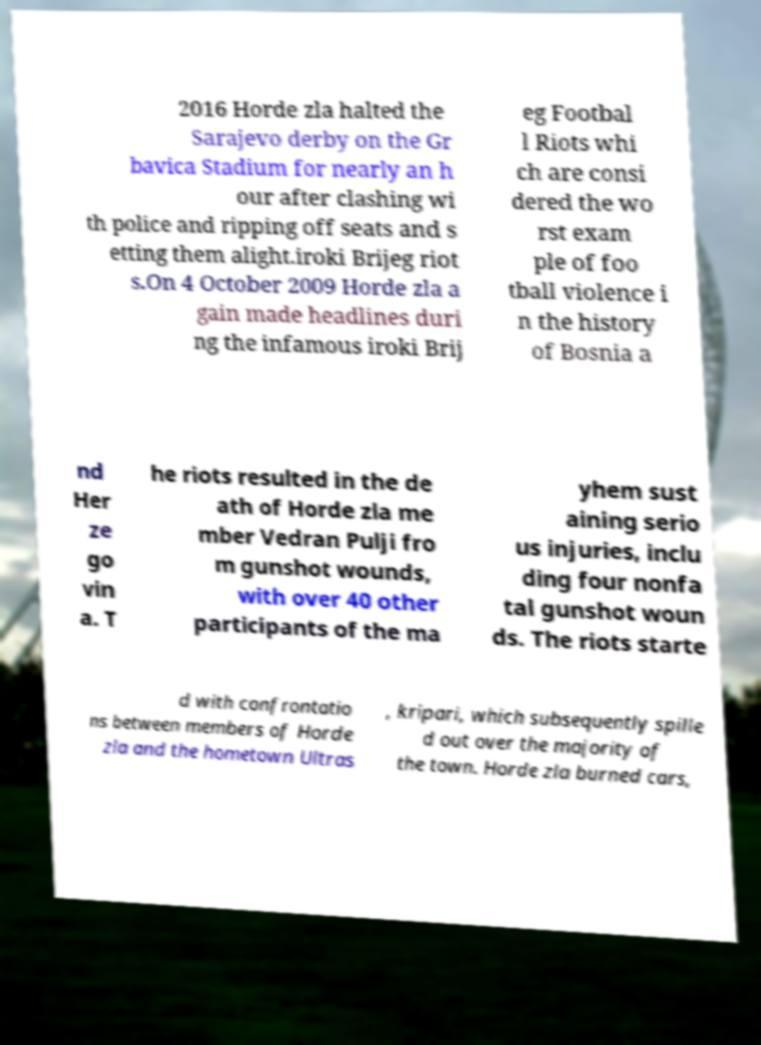Please identify and transcribe the text found in this image. 2016 Horde zla halted the Sarajevo derby on the Gr bavica Stadium for nearly an h our after clashing wi th police and ripping off seats and s etting them alight.iroki Brijeg riot s.On 4 October 2009 Horde zla a gain made headlines duri ng the infamous iroki Brij eg Footbal l Riots whi ch are consi dered the wo rst exam ple of foo tball violence i n the history of Bosnia a nd Her ze go vin a. T he riots resulted in the de ath of Horde zla me mber Vedran Pulji fro m gunshot wounds, with over 40 other participants of the ma yhem sust aining serio us injuries, inclu ding four nonfa tal gunshot woun ds. The riots starte d with confrontatio ns between members of Horde zla and the hometown Ultras , kripari, which subsequently spille d out over the majority of the town. Horde zla burned cars, 